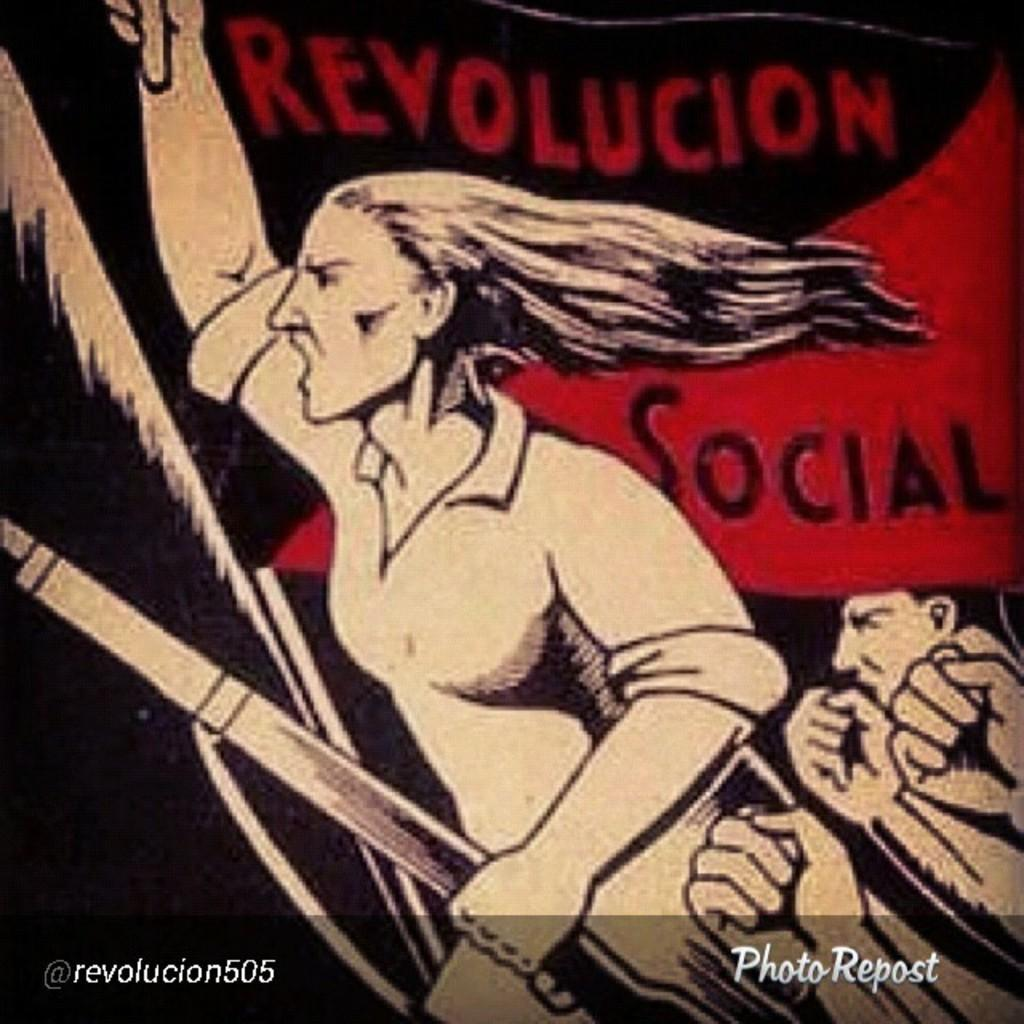<image>
Relay a brief, clear account of the picture shown. a photo repost that says 'revolucion social' on it 